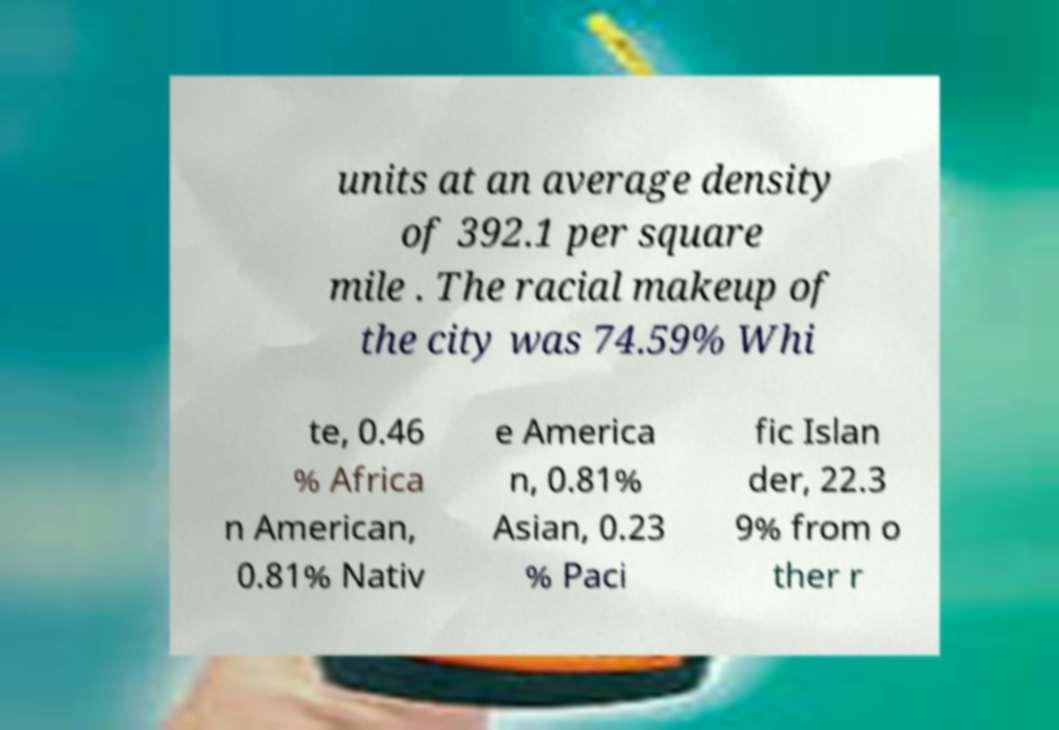Could you assist in decoding the text presented in this image and type it out clearly? units at an average density of 392.1 per square mile . The racial makeup of the city was 74.59% Whi te, 0.46 % Africa n American, 0.81% Nativ e America n, 0.81% Asian, 0.23 % Paci fic Islan der, 22.3 9% from o ther r 